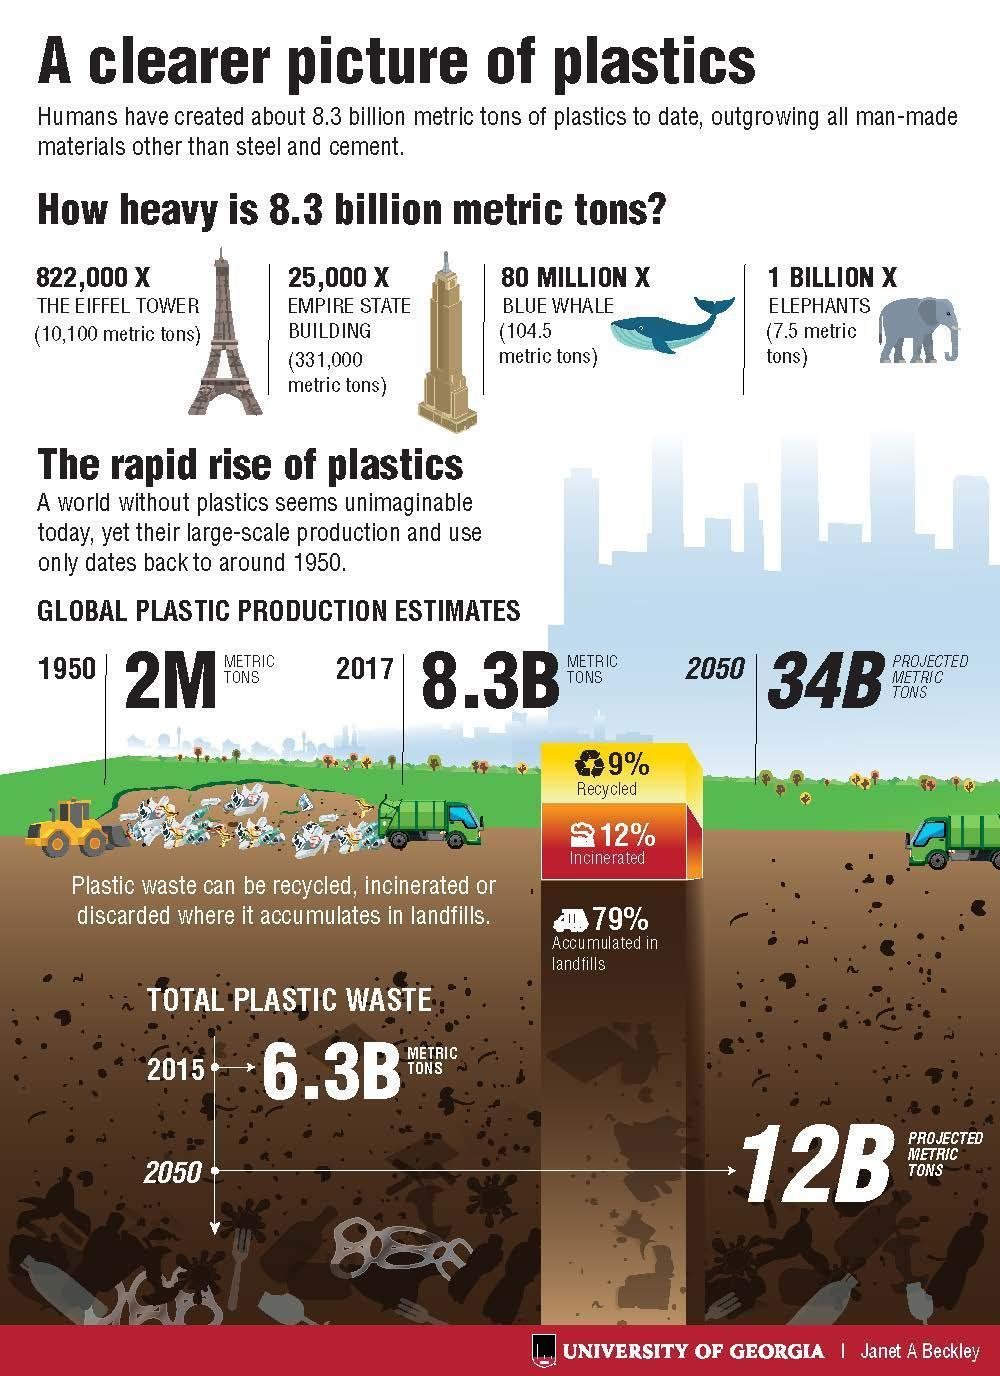What percentage of plastic waste are incinerated?
Answer the question with a short phrase. 12% What percentage of plastic waste were not accumulated in landfills? 21% What is the projected estimate of global plastic production in 2050? 34B PROJECTED METRIC TONS What is the estimated global plastic production in 2017? 8.3B METRIC TONS 